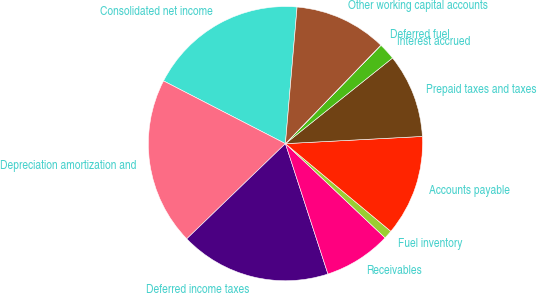Convert chart. <chart><loc_0><loc_0><loc_500><loc_500><pie_chart><fcel>Consolidated net income<fcel>Depreciation amortization and<fcel>Deferred income taxes<fcel>Receivables<fcel>Fuel inventory<fcel>Accounts payable<fcel>Prepaid taxes and taxes<fcel>Interest accrued<fcel>Deferred fuel<fcel>Other working capital accounts<nl><fcel>18.79%<fcel>19.78%<fcel>17.8%<fcel>7.93%<fcel>1.01%<fcel>11.88%<fcel>9.9%<fcel>2.0%<fcel>0.02%<fcel>10.89%<nl></chart> 